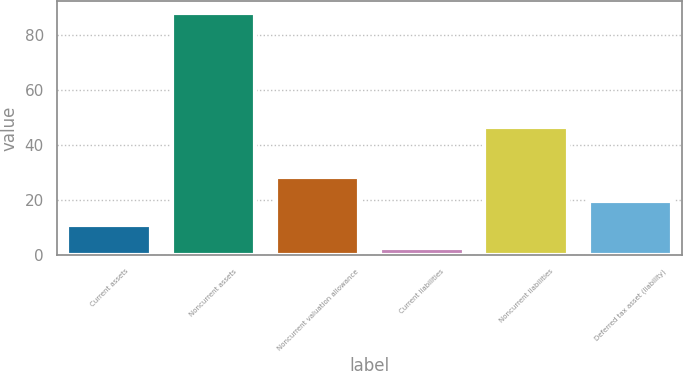<chart> <loc_0><loc_0><loc_500><loc_500><bar_chart><fcel>Current assets<fcel>Noncurrent assets<fcel>Noncurrent valuation allowance<fcel>Current liabilities<fcel>Noncurrent liabilities<fcel>Deferred tax asset (liability)<nl><fcel>11.05<fcel>88<fcel>28.15<fcel>2.5<fcel>46.6<fcel>19.6<nl></chart> 